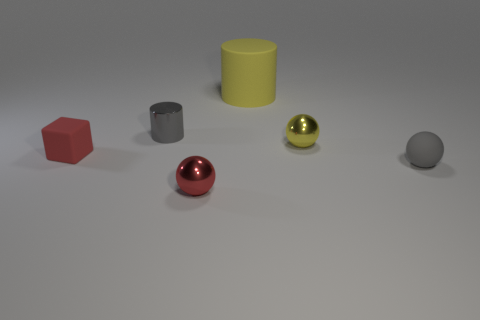Subtract all metal balls. How many balls are left? 1 Add 3 matte blocks. How many objects exist? 9 Subtract all brown spheres. Subtract all cyan blocks. How many spheres are left? 3 Subtract all blocks. How many objects are left? 5 Subtract 0 brown cylinders. How many objects are left? 6 Subtract all small red shiny things. Subtract all purple rubber spheres. How many objects are left? 5 Add 4 gray metallic cylinders. How many gray metallic cylinders are left? 5 Add 3 red balls. How many red balls exist? 4 